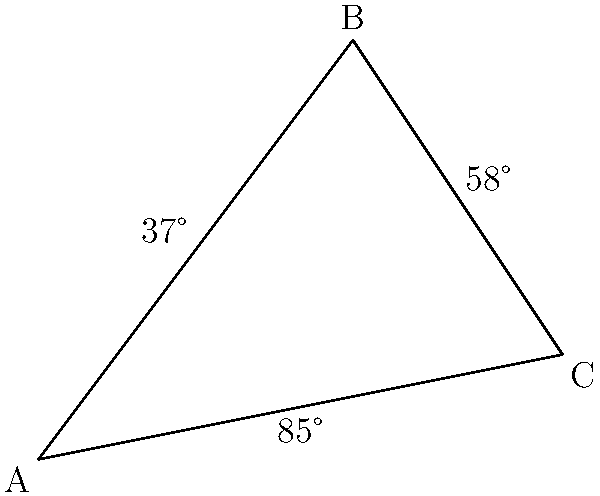In a branching coral structure, three distinct branch tips form a triangle ABC as shown in the figure. The angles between these branches are measured to assess reef complexity. Given that angle BAC is 37° and angle ABC is 58°, what is the measure of angle BCA? To solve this problem, we'll use the principle that the sum of angles in a triangle is always 180°. Here's the step-by-step solution:

1. Let's define our known angles:
   $\angle BAC = 37°$
   $\angle ABC = 58°$

2. Let $x$ be the measure of $\angle BCA$ that we're trying to find.

3. We know that in any triangle, the sum of all angles is 180°. So we can write:
   $\angle BAC + \angle ABC + \angle BCA = 180°$

4. Substituting our known values and the variable $x$:
   $37° + 58° + x = 180°$

5. Simplify the left side of the equation:
   $95° + x = 180°$

6. Subtract 95° from both sides:
   $x = 180° - 95° = 85°$

Therefore, the measure of angle BCA is 85°.

This measurement helps in quantifying the structural complexity of the coral, which is an important factor in assessing reef health and biodiversity.
Answer: 85° 